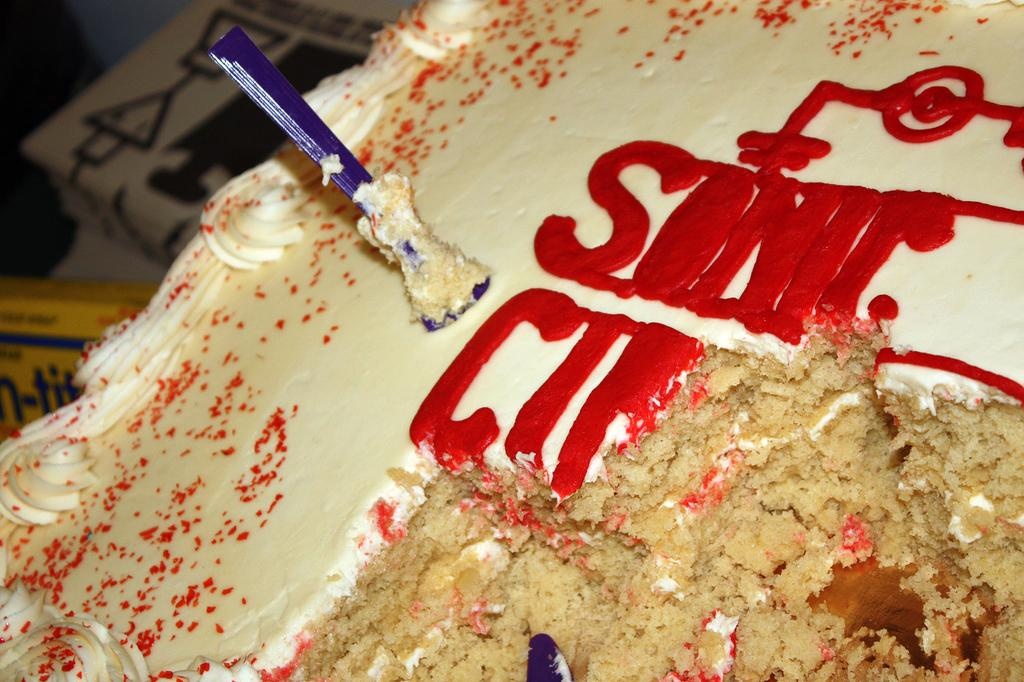What is the main subject of the image? The main subject of the image is food. Where is the food located in the image? The food is in the front of the image. What else can be seen on the left side of the image? There are boxes on the left side of the image. What colors are the boxes? The boxes are yellow and brown in color. What type of print can be seen on the pie in the image? There is no pie present in the image, so it is not possible to determine if there is any print on it. 